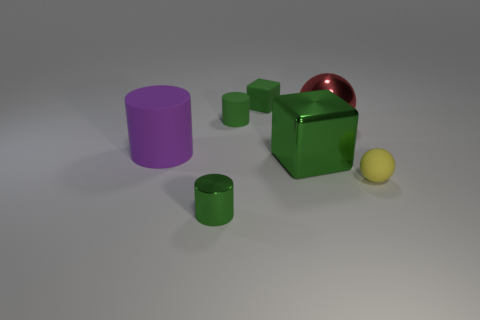Are the big object behind the big purple matte cylinder and the green cylinder that is behind the big red metal sphere made of the same material?
Keep it short and to the point. No. Is there a small blue rubber object?
Provide a short and direct response. No. Is the number of tiny cylinders that are on the left side of the big matte cylinder greater than the number of small green shiny cylinders right of the small green metallic cylinder?
Ensure brevity in your answer.  No. What material is the tiny yellow thing that is the same shape as the large red metal object?
Make the answer very short. Rubber. Are there any other things that have the same size as the yellow ball?
Provide a succinct answer. Yes. There is a sphere that is behind the yellow rubber sphere; is it the same color as the cylinder that is behind the large red metal ball?
Keep it short and to the point. No. There is a large purple rubber thing; what shape is it?
Give a very brief answer. Cylinder. Is the number of small green rubber cylinders in front of the big green thing greater than the number of matte blocks?
Keep it short and to the point. No. There is a green object that is to the right of the small green rubber cube; what is its shape?
Offer a terse response. Cube. How many other things are there of the same shape as the large rubber object?
Your answer should be very brief. 2. 